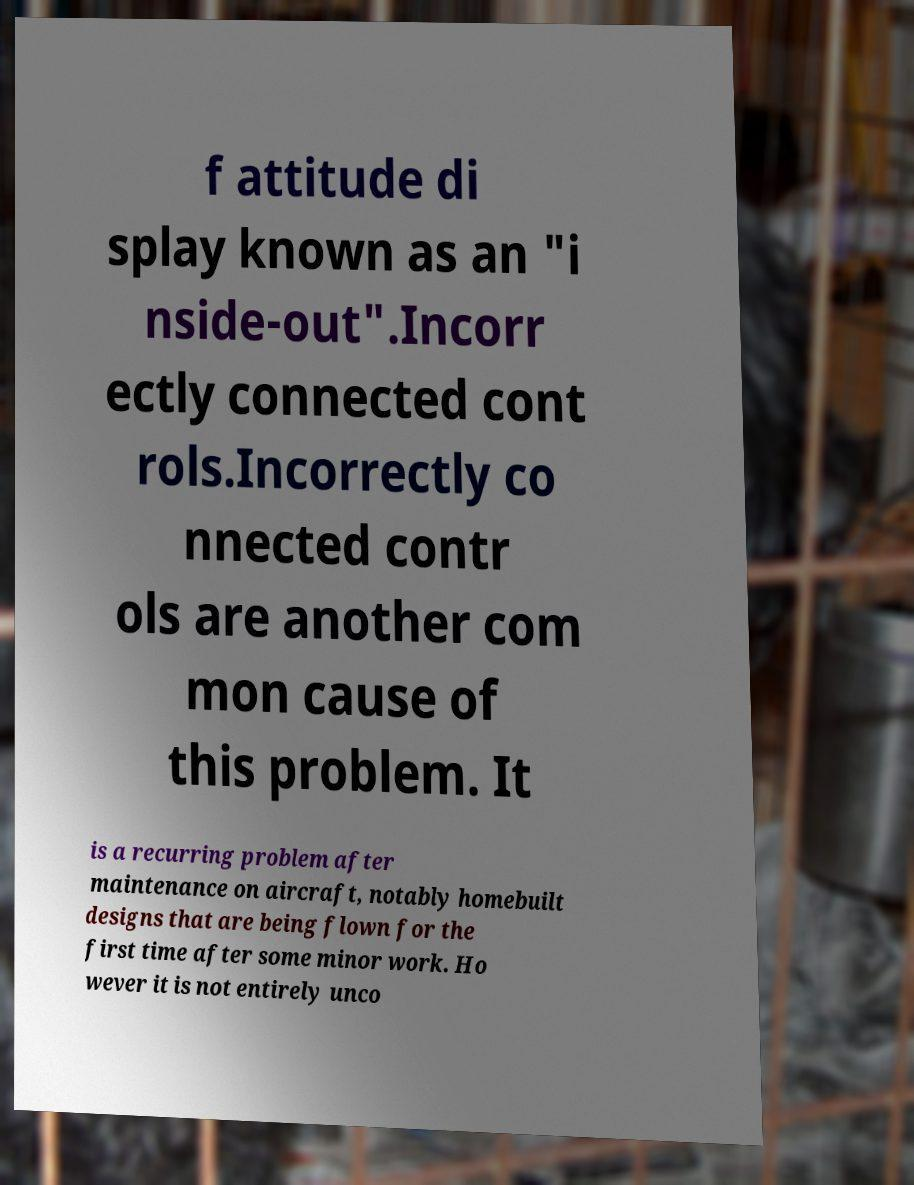What messages or text are displayed in this image? I need them in a readable, typed format. f attitude di splay known as an "i nside-out".Incorr ectly connected cont rols.Incorrectly co nnected contr ols are another com mon cause of this problem. It is a recurring problem after maintenance on aircraft, notably homebuilt designs that are being flown for the first time after some minor work. Ho wever it is not entirely unco 